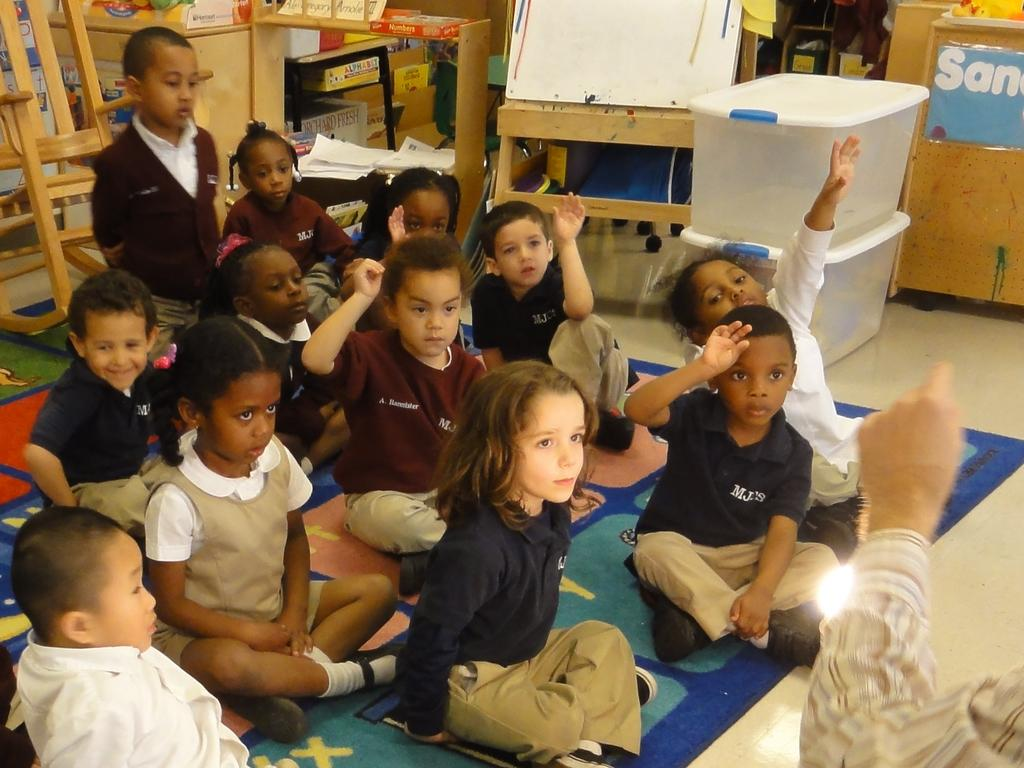What are the kids doing in the image? The kids are seated in the image. What can be seen in the hand of the person in the image? There is a human hand holding a light in the image. What type of furniture is present in the image? There is a chair in the image. What objects are present in the image that might be used for storage or organization? There are boxes in the image. What surface is visible in the image that might be used for writing or displaying information? There is a board in the image. What type of butter is being used to power the light in the image? There is no butter present in the image, and the light is not powered by any type of butter. 